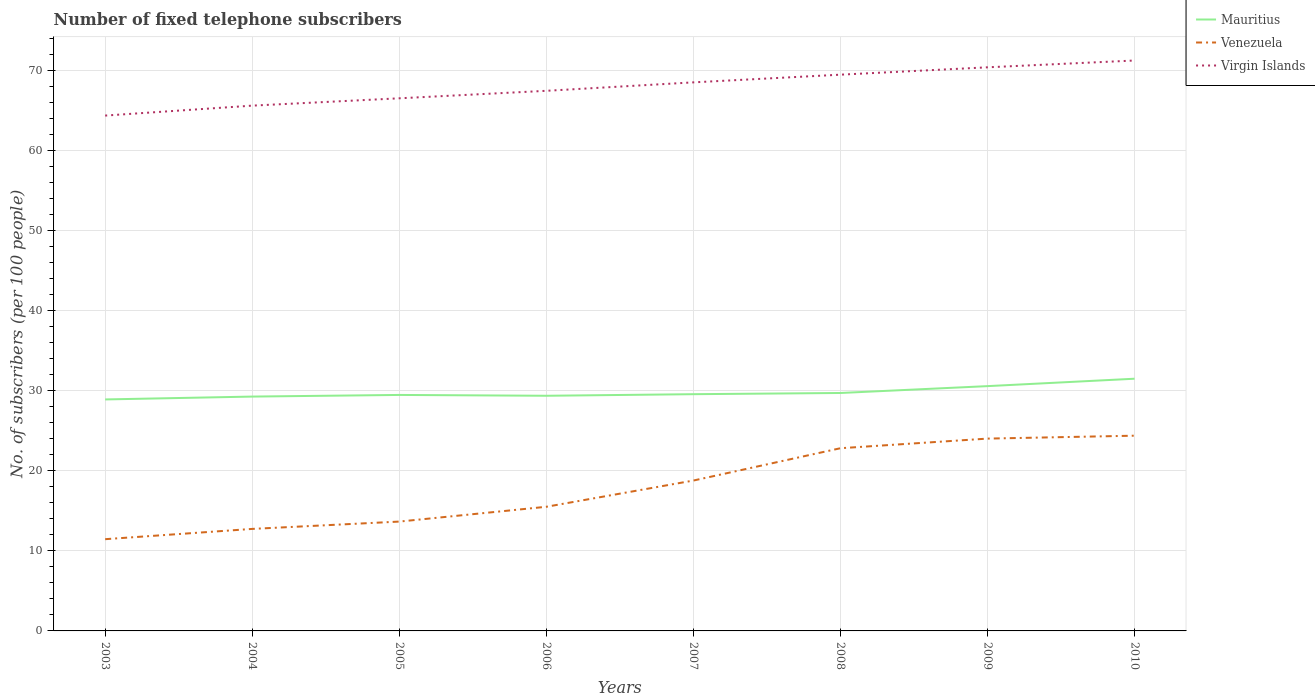Does the line corresponding to Venezuela intersect with the line corresponding to Mauritius?
Your answer should be very brief. No. Across all years, what is the maximum number of fixed telephone subscribers in Virgin Islands?
Offer a very short reply. 64.37. In which year was the number of fixed telephone subscribers in Venezuela maximum?
Your answer should be compact. 2003. What is the total number of fixed telephone subscribers in Venezuela in the graph?
Make the answer very short. -10.08. What is the difference between the highest and the second highest number of fixed telephone subscribers in Virgin Islands?
Give a very brief answer. 6.88. What is the difference between the highest and the lowest number of fixed telephone subscribers in Virgin Islands?
Make the answer very short. 4. What is the difference between two consecutive major ticks on the Y-axis?
Provide a short and direct response. 10. Are the values on the major ticks of Y-axis written in scientific E-notation?
Make the answer very short. No. Does the graph contain any zero values?
Provide a succinct answer. No. How many legend labels are there?
Your answer should be compact. 3. How are the legend labels stacked?
Give a very brief answer. Vertical. What is the title of the graph?
Offer a very short reply. Number of fixed telephone subscribers. Does "Papua New Guinea" appear as one of the legend labels in the graph?
Your response must be concise. No. What is the label or title of the Y-axis?
Provide a short and direct response. No. of subscribers (per 100 people). What is the No. of subscribers (per 100 people) in Mauritius in 2003?
Ensure brevity in your answer.  28.92. What is the No. of subscribers (per 100 people) in Venezuela in 2003?
Provide a succinct answer. 11.46. What is the No. of subscribers (per 100 people) of Virgin Islands in 2003?
Give a very brief answer. 64.37. What is the No. of subscribers (per 100 people) in Mauritius in 2004?
Ensure brevity in your answer.  29.27. What is the No. of subscribers (per 100 people) of Venezuela in 2004?
Your response must be concise. 12.74. What is the No. of subscribers (per 100 people) of Virgin Islands in 2004?
Make the answer very short. 65.62. What is the No. of subscribers (per 100 people) in Mauritius in 2005?
Offer a very short reply. 29.48. What is the No. of subscribers (per 100 people) of Venezuela in 2005?
Ensure brevity in your answer.  13.66. What is the No. of subscribers (per 100 people) of Virgin Islands in 2005?
Offer a terse response. 66.53. What is the No. of subscribers (per 100 people) in Mauritius in 2006?
Provide a short and direct response. 29.37. What is the No. of subscribers (per 100 people) in Venezuela in 2006?
Make the answer very short. 15.51. What is the No. of subscribers (per 100 people) in Virgin Islands in 2006?
Offer a terse response. 67.47. What is the No. of subscribers (per 100 people) in Mauritius in 2007?
Offer a very short reply. 29.57. What is the No. of subscribers (per 100 people) in Venezuela in 2007?
Your answer should be compact. 18.78. What is the No. of subscribers (per 100 people) of Virgin Islands in 2007?
Your answer should be compact. 68.52. What is the No. of subscribers (per 100 people) of Mauritius in 2008?
Make the answer very short. 29.72. What is the No. of subscribers (per 100 people) of Venezuela in 2008?
Provide a succinct answer. 22.82. What is the No. of subscribers (per 100 people) in Virgin Islands in 2008?
Give a very brief answer. 69.48. What is the No. of subscribers (per 100 people) of Mauritius in 2009?
Offer a very short reply. 30.58. What is the No. of subscribers (per 100 people) in Venezuela in 2009?
Your response must be concise. 24.02. What is the No. of subscribers (per 100 people) of Virgin Islands in 2009?
Your response must be concise. 70.4. What is the No. of subscribers (per 100 people) in Mauritius in 2010?
Provide a short and direct response. 31.5. What is the No. of subscribers (per 100 people) in Venezuela in 2010?
Keep it short and to the point. 24.39. What is the No. of subscribers (per 100 people) of Virgin Islands in 2010?
Make the answer very short. 71.25. Across all years, what is the maximum No. of subscribers (per 100 people) in Mauritius?
Ensure brevity in your answer.  31.5. Across all years, what is the maximum No. of subscribers (per 100 people) of Venezuela?
Make the answer very short. 24.39. Across all years, what is the maximum No. of subscribers (per 100 people) of Virgin Islands?
Your answer should be very brief. 71.25. Across all years, what is the minimum No. of subscribers (per 100 people) in Mauritius?
Provide a short and direct response. 28.92. Across all years, what is the minimum No. of subscribers (per 100 people) of Venezuela?
Keep it short and to the point. 11.46. Across all years, what is the minimum No. of subscribers (per 100 people) in Virgin Islands?
Your answer should be very brief. 64.37. What is the total No. of subscribers (per 100 people) in Mauritius in the graph?
Keep it short and to the point. 238.42. What is the total No. of subscribers (per 100 people) in Venezuela in the graph?
Make the answer very short. 143.39. What is the total No. of subscribers (per 100 people) in Virgin Islands in the graph?
Give a very brief answer. 543.65. What is the difference between the No. of subscribers (per 100 people) in Mauritius in 2003 and that in 2004?
Provide a succinct answer. -0.36. What is the difference between the No. of subscribers (per 100 people) of Venezuela in 2003 and that in 2004?
Keep it short and to the point. -1.28. What is the difference between the No. of subscribers (per 100 people) in Virgin Islands in 2003 and that in 2004?
Your response must be concise. -1.24. What is the difference between the No. of subscribers (per 100 people) of Mauritius in 2003 and that in 2005?
Offer a very short reply. -0.56. What is the difference between the No. of subscribers (per 100 people) in Venezuela in 2003 and that in 2005?
Provide a succinct answer. -2.2. What is the difference between the No. of subscribers (per 100 people) of Virgin Islands in 2003 and that in 2005?
Your answer should be compact. -2.16. What is the difference between the No. of subscribers (per 100 people) of Mauritius in 2003 and that in 2006?
Your answer should be compact. -0.46. What is the difference between the No. of subscribers (per 100 people) of Venezuela in 2003 and that in 2006?
Keep it short and to the point. -4.05. What is the difference between the No. of subscribers (per 100 people) in Virgin Islands in 2003 and that in 2006?
Your response must be concise. -3.09. What is the difference between the No. of subscribers (per 100 people) of Mauritius in 2003 and that in 2007?
Ensure brevity in your answer.  -0.65. What is the difference between the No. of subscribers (per 100 people) in Venezuela in 2003 and that in 2007?
Keep it short and to the point. -7.33. What is the difference between the No. of subscribers (per 100 people) in Virgin Islands in 2003 and that in 2007?
Ensure brevity in your answer.  -4.15. What is the difference between the No. of subscribers (per 100 people) in Mauritius in 2003 and that in 2008?
Give a very brief answer. -0.81. What is the difference between the No. of subscribers (per 100 people) of Venezuela in 2003 and that in 2008?
Make the answer very short. -11.36. What is the difference between the No. of subscribers (per 100 people) of Virgin Islands in 2003 and that in 2008?
Make the answer very short. -5.11. What is the difference between the No. of subscribers (per 100 people) of Mauritius in 2003 and that in 2009?
Offer a very short reply. -1.66. What is the difference between the No. of subscribers (per 100 people) in Venezuela in 2003 and that in 2009?
Offer a terse response. -12.56. What is the difference between the No. of subscribers (per 100 people) of Virgin Islands in 2003 and that in 2009?
Offer a terse response. -6.03. What is the difference between the No. of subscribers (per 100 people) of Mauritius in 2003 and that in 2010?
Offer a terse response. -2.59. What is the difference between the No. of subscribers (per 100 people) in Venezuela in 2003 and that in 2010?
Offer a very short reply. -12.93. What is the difference between the No. of subscribers (per 100 people) in Virgin Islands in 2003 and that in 2010?
Your answer should be compact. -6.88. What is the difference between the No. of subscribers (per 100 people) of Mauritius in 2004 and that in 2005?
Provide a succinct answer. -0.2. What is the difference between the No. of subscribers (per 100 people) of Venezuela in 2004 and that in 2005?
Give a very brief answer. -0.92. What is the difference between the No. of subscribers (per 100 people) in Virgin Islands in 2004 and that in 2005?
Ensure brevity in your answer.  -0.92. What is the difference between the No. of subscribers (per 100 people) of Mauritius in 2004 and that in 2006?
Provide a succinct answer. -0.1. What is the difference between the No. of subscribers (per 100 people) in Venezuela in 2004 and that in 2006?
Ensure brevity in your answer.  -2.77. What is the difference between the No. of subscribers (per 100 people) of Virgin Islands in 2004 and that in 2006?
Offer a very short reply. -1.85. What is the difference between the No. of subscribers (per 100 people) of Mauritius in 2004 and that in 2007?
Your answer should be very brief. -0.3. What is the difference between the No. of subscribers (per 100 people) of Venezuela in 2004 and that in 2007?
Offer a terse response. -6.04. What is the difference between the No. of subscribers (per 100 people) of Virgin Islands in 2004 and that in 2007?
Provide a succinct answer. -2.91. What is the difference between the No. of subscribers (per 100 people) in Mauritius in 2004 and that in 2008?
Your response must be concise. -0.45. What is the difference between the No. of subscribers (per 100 people) of Venezuela in 2004 and that in 2008?
Make the answer very short. -10.08. What is the difference between the No. of subscribers (per 100 people) in Virgin Islands in 2004 and that in 2008?
Give a very brief answer. -3.87. What is the difference between the No. of subscribers (per 100 people) of Mauritius in 2004 and that in 2009?
Give a very brief answer. -1.31. What is the difference between the No. of subscribers (per 100 people) in Venezuela in 2004 and that in 2009?
Provide a short and direct response. -11.28. What is the difference between the No. of subscribers (per 100 people) of Virgin Islands in 2004 and that in 2009?
Keep it short and to the point. -4.79. What is the difference between the No. of subscribers (per 100 people) of Mauritius in 2004 and that in 2010?
Offer a very short reply. -2.23. What is the difference between the No. of subscribers (per 100 people) of Venezuela in 2004 and that in 2010?
Offer a very short reply. -11.64. What is the difference between the No. of subscribers (per 100 people) of Virgin Islands in 2004 and that in 2010?
Your answer should be very brief. -5.64. What is the difference between the No. of subscribers (per 100 people) in Mauritius in 2005 and that in 2006?
Give a very brief answer. 0.1. What is the difference between the No. of subscribers (per 100 people) of Venezuela in 2005 and that in 2006?
Provide a succinct answer. -1.85. What is the difference between the No. of subscribers (per 100 people) in Virgin Islands in 2005 and that in 2006?
Offer a terse response. -0.94. What is the difference between the No. of subscribers (per 100 people) of Mauritius in 2005 and that in 2007?
Your answer should be compact. -0.09. What is the difference between the No. of subscribers (per 100 people) in Venezuela in 2005 and that in 2007?
Provide a succinct answer. -5.13. What is the difference between the No. of subscribers (per 100 people) in Virgin Islands in 2005 and that in 2007?
Your answer should be very brief. -1.99. What is the difference between the No. of subscribers (per 100 people) in Mauritius in 2005 and that in 2008?
Offer a very short reply. -0.24. What is the difference between the No. of subscribers (per 100 people) in Venezuela in 2005 and that in 2008?
Provide a short and direct response. -9.16. What is the difference between the No. of subscribers (per 100 people) of Virgin Islands in 2005 and that in 2008?
Your answer should be very brief. -2.95. What is the difference between the No. of subscribers (per 100 people) in Mauritius in 2005 and that in 2009?
Offer a very short reply. -1.1. What is the difference between the No. of subscribers (per 100 people) in Venezuela in 2005 and that in 2009?
Your response must be concise. -10.36. What is the difference between the No. of subscribers (per 100 people) in Virgin Islands in 2005 and that in 2009?
Your answer should be very brief. -3.87. What is the difference between the No. of subscribers (per 100 people) of Mauritius in 2005 and that in 2010?
Offer a terse response. -2.03. What is the difference between the No. of subscribers (per 100 people) of Venezuela in 2005 and that in 2010?
Offer a very short reply. -10.73. What is the difference between the No. of subscribers (per 100 people) in Virgin Islands in 2005 and that in 2010?
Make the answer very short. -4.72. What is the difference between the No. of subscribers (per 100 people) in Mauritius in 2006 and that in 2007?
Give a very brief answer. -0.2. What is the difference between the No. of subscribers (per 100 people) in Venezuela in 2006 and that in 2007?
Offer a very short reply. -3.28. What is the difference between the No. of subscribers (per 100 people) in Virgin Islands in 2006 and that in 2007?
Give a very brief answer. -1.06. What is the difference between the No. of subscribers (per 100 people) of Mauritius in 2006 and that in 2008?
Give a very brief answer. -0.35. What is the difference between the No. of subscribers (per 100 people) of Venezuela in 2006 and that in 2008?
Give a very brief answer. -7.31. What is the difference between the No. of subscribers (per 100 people) of Virgin Islands in 2006 and that in 2008?
Offer a terse response. -2.02. What is the difference between the No. of subscribers (per 100 people) of Mauritius in 2006 and that in 2009?
Offer a very short reply. -1.21. What is the difference between the No. of subscribers (per 100 people) in Venezuela in 2006 and that in 2009?
Offer a terse response. -8.52. What is the difference between the No. of subscribers (per 100 people) of Virgin Islands in 2006 and that in 2009?
Make the answer very short. -2.93. What is the difference between the No. of subscribers (per 100 people) in Mauritius in 2006 and that in 2010?
Ensure brevity in your answer.  -2.13. What is the difference between the No. of subscribers (per 100 people) in Venezuela in 2006 and that in 2010?
Your answer should be very brief. -8.88. What is the difference between the No. of subscribers (per 100 people) in Virgin Islands in 2006 and that in 2010?
Ensure brevity in your answer.  -3.78. What is the difference between the No. of subscribers (per 100 people) in Mauritius in 2007 and that in 2008?
Offer a very short reply. -0.15. What is the difference between the No. of subscribers (per 100 people) in Venezuela in 2007 and that in 2008?
Your answer should be compact. -4.04. What is the difference between the No. of subscribers (per 100 people) in Virgin Islands in 2007 and that in 2008?
Provide a short and direct response. -0.96. What is the difference between the No. of subscribers (per 100 people) of Mauritius in 2007 and that in 2009?
Your answer should be very brief. -1.01. What is the difference between the No. of subscribers (per 100 people) in Venezuela in 2007 and that in 2009?
Provide a succinct answer. -5.24. What is the difference between the No. of subscribers (per 100 people) in Virgin Islands in 2007 and that in 2009?
Offer a terse response. -1.88. What is the difference between the No. of subscribers (per 100 people) of Mauritius in 2007 and that in 2010?
Make the answer very short. -1.93. What is the difference between the No. of subscribers (per 100 people) in Venezuela in 2007 and that in 2010?
Your answer should be very brief. -5.6. What is the difference between the No. of subscribers (per 100 people) in Virgin Islands in 2007 and that in 2010?
Keep it short and to the point. -2.73. What is the difference between the No. of subscribers (per 100 people) in Mauritius in 2008 and that in 2009?
Offer a very short reply. -0.86. What is the difference between the No. of subscribers (per 100 people) of Venezuela in 2008 and that in 2009?
Provide a short and direct response. -1.2. What is the difference between the No. of subscribers (per 100 people) in Virgin Islands in 2008 and that in 2009?
Your response must be concise. -0.92. What is the difference between the No. of subscribers (per 100 people) of Mauritius in 2008 and that in 2010?
Provide a short and direct response. -1.78. What is the difference between the No. of subscribers (per 100 people) in Venezuela in 2008 and that in 2010?
Your response must be concise. -1.56. What is the difference between the No. of subscribers (per 100 people) of Virgin Islands in 2008 and that in 2010?
Provide a short and direct response. -1.77. What is the difference between the No. of subscribers (per 100 people) in Mauritius in 2009 and that in 2010?
Keep it short and to the point. -0.92. What is the difference between the No. of subscribers (per 100 people) in Venezuela in 2009 and that in 2010?
Your response must be concise. -0.36. What is the difference between the No. of subscribers (per 100 people) of Virgin Islands in 2009 and that in 2010?
Offer a terse response. -0.85. What is the difference between the No. of subscribers (per 100 people) in Mauritius in 2003 and the No. of subscribers (per 100 people) in Venezuela in 2004?
Ensure brevity in your answer.  16.17. What is the difference between the No. of subscribers (per 100 people) of Mauritius in 2003 and the No. of subscribers (per 100 people) of Virgin Islands in 2004?
Your answer should be compact. -36.7. What is the difference between the No. of subscribers (per 100 people) of Venezuela in 2003 and the No. of subscribers (per 100 people) of Virgin Islands in 2004?
Provide a short and direct response. -54.16. What is the difference between the No. of subscribers (per 100 people) in Mauritius in 2003 and the No. of subscribers (per 100 people) in Venezuela in 2005?
Provide a succinct answer. 15.26. What is the difference between the No. of subscribers (per 100 people) in Mauritius in 2003 and the No. of subscribers (per 100 people) in Virgin Islands in 2005?
Ensure brevity in your answer.  -37.62. What is the difference between the No. of subscribers (per 100 people) of Venezuela in 2003 and the No. of subscribers (per 100 people) of Virgin Islands in 2005?
Offer a very short reply. -55.07. What is the difference between the No. of subscribers (per 100 people) in Mauritius in 2003 and the No. of subscribers (per 100 people) in Venezuela in 2006?
Offer a very short reply. 13.41. What is the difference between the No. of subscribers (per 100 people) of Mauritius in 2003 and the No. of subscribers (per 100 people) of Virgin Islands in 2006?
Your answer should be very brief. -38.55. What is the difference between the No. of subscribers (per 100 people) in Venezuela in 2003 and the No. of subscribers (per 100 people) in Virgin Islands in 2006?
Your answer should be compact. -56.01. What is the difference between the No. of subscribers (per 100 people) of Mauritius in 2003 and the No. of subscribers (per 100 people) of Venezuela in 2007?
Provide a short and direct response. 10.13. What is the difference between the No. of subscribers (per 100 people) of Mauritius in 2003 and the No. of subscribers (per 100 people) of Virgin Islands in 2007?
Give a very brief answer. -39.61. What is the difference between the No. of subscribers (per 100 people) in Venezuela in 2003 and the No. of subscribers (per 100 people) in Virgin Islands in 2007?
Ensure brevity in your answer.  -57.06. What is the difference between the No. of subscribers (per 100 people) in Mauritius in 2003 and the No. of subscribers (per 100 people) in Venezuela in 2008?
Provide a succinct answer. 6.09. What is the difference between the No. of subscribers (per 100 people) of Mauritius in 2003 and the No. of subscribers (per 100 people) of Virgin Islands in 2008?
Make the answer very short. -40.57. What is the difference between the No. of subscribers (per 100 people) of Venezuela in 2003 and the No. of subscribers (per 100 people) of Virgin Islands in 2008?
Provide a succinct answer. -58.02. What is the difference between the No. of subscribers (per 100 people) in Mauritius in 2003 and the No. of subscribers (per 100 people) in Venezuela in 2009?
Your response must be concise. 4.89. What is the difference between the No. of subscribers (per 100 people) in Mauritius in 2003 and the No. of subscribers (per 100 people) in Virgin Islands in 2009?
Offer a very short reply. -41.49. What is the difference between the No. of subscribers (per 100 people) of Venezuela in 2003 and the No. of subscribers (per 100 people) of Virgin Islands in 2009?
Make the answer very short. -58.94. What is the difference between the No. of subscribers (per 100 people) in Mauritius in 2003 and the No. of subscribers (per 100 people) in Venezuela in 2010?
Your response must be concise. 4.53. What is the difference between the No. of subscribers (per 100 people) of Mauritius in 2003 and the No. of subscribers (per 100 people) of Virgin Islands in 2010?
Keep it short and to the point. -42.34. What is the difference between the No. of subscribers (per 100 people) in Venezuela in 2003 and the No. of subscribers (per 100 people) in Virgin Islands in 2010?
Keep it short and to the point. -59.79. What is the difference between the No. of subscribers (per 100 people) of Mauritius in 2004 and the No. of subscribers (per 100 people) of Venezuela in 2005?
Give a very brief answer. 15.61. What is the difference between the No. of subscribers (per 100 people) of Mauritius in 2004 and the No. of subscribers (per 100 people) of Virgin Islands in 2005?
Provide a short and direct response. -37.26. What is the difference between the No. of subscribers (per 100 people) in Venezuela in 2004 and the No. of subscribers (per 100 people) in Virgin Islands in 2005?
Your response must be concise. -53.79. What is the difference between the No. of subscribers (per 100 people) of Mauritius in 2004 and the No. of subscribers (per 100 people) of Venezuela in 2006?
Offer a very short reply. 13.76. What is the difference between the No. of subscribers (per 100 people) of Mauritius in 2004 and the No. of subscribers (per 100 people) of Virgin Islands in 2006?
Provide a short and direct response. -38.2. What is the difference between the No. of subscribers (per 100 people) of Venezuela in 2004 and the No. of subscribers (per 100 people) of Virgin Islands in 2006?
Ensure brevity in your answer.  -54.73. What is the difference between the No. of subscribers (per 100 people) of Mauritius in 2004 and the No. of subscribers (per 100 people) of Venezuela in 2007?
Your answer should be very brief. 10.49. What is the difference between the No. of subscribers (per 100 people) of Mauritius in 2004 and the No. of subscribers (per 100 people) of Virgin Islands in 2007?
Provide a succinct answer. -39.25. What is the difference between the No. of subscribers (per 100 people) in Venezuela in 2004 and the No. of subscribers (per 100 people) in Virgin Islands in 2007?
Ensure brevity in your answer.  -55.78. What is the difference between the No. of subscribers (per 100 people) in Mauritius in 2004 and the No. of subscribers (per 100 people) in Venezuela in 2008?
Your response must be concise. 6.45. What is the difference between the No. of subscribers (per 100 people) in Mauritius in 2004 and the No. of subscribers (per 100 people) in Virgin Islands in 2008?
Offer a terse response. -40.21. What is the difference between the No. of subscribers (per 100 people) of Venezuela in 2004 and the No. of subscribers (per 100 people) of Virgin Islands in 2008?
Offer a terse response. -56.74. What is the difference between the No. of subscribers (per 100 people) of Mauritius in 2004 and the No. of subscribers (per 100 people) of Venezuela in 2009?
Provide a short and direct response. 5.25. What is the difference between the No. of subscribers (per 100 people) of Mauritius in 2004 and the No. of subscribers (per 100 people) of Virgin Islands in 2009?
Keep it short and to the point. -41.13. What is the difference between the No. of subscribers (per 100 people) in Venezuela in 2004 and the No. of subscribers (per 100 people) in Virgin Islands in 2009?
Keep it short and to the point. -57.66. What is the difference between the No. of subscribers (per 100 people) in Mauritius in 2004 and the No. of subscribers (per 100 people) in Venezuela in 2010?
Keep it short and to the point. 4.89. What is the difference between the No. of subscribers (per 100 people) in Mauritius in 2004 and the No. of subscribers (per 100 people) in Virgin Islands in 2010?
Keep it short and to the point. -41.98. What is the difference between the No. of subscribers (per 100 people) of Venezuela in 2004 and the No. of subscribers (per 100 people) of Virgin Islands in 2010?
Keep it short and to the point. -58.51. What is the difference between the No. of subscribers (per 100 people) of Mauritius in 2005 and the No. of subscribers (per 100 people) of Venezuela in 2006?
Give a very brief answer. 13.97. What is the difference between the No. of subscribers (per 100 people) of Mauritius in 2005 and the No. of subscribers (per 100 people) of Virgin Islands in 2006?
Provide a short and direct response. -37.99. What is the difference between the No. of subscribers (per 100 people) in Venezuela in 2005 and the No. of subscribers (per 100 people) in Virgin Islands in 2006?
Provide a short and direct response. -53.81. What is the difference between the No. of subscribers (per 100 people) of Mauritius in 2005 and the No. of subscribers (per 100 people) of Venezuela in 2007?
Give a very brief answer. 10.69. What is the difference between the No. of subscribers (per 100 people) of Mauritius in 2005 and the No. of subscribers (per 100 people) of Virgin Islands in 2007?
Provide a short and direct response. -39.05. What is the difference between the No. of subscribers (per 100 people) of Venezuela in 2005 and the No. of subscribers (per 100 people) of Virgin Islands in 2007?
Offer a very short reply. -54.86. What is the difference between the No. of subscribers (per 100 people) of Mauritius in 2005 and the No. of subscribers (per 100 people) of Venezuela in 2008?
Make the answer very short. 6.66. What is the difference between the No. of subscribers (per 100 people) of Mauritius in 2005 and the No. of subscribers (per 100 people) of Virgin Islands in 2008?
Offer a very short reply. -40.01. What is the difference between the No. of subscribers (per 100 people) of Venezuela in 2005 and the No. of subscribers (per 100 people) of Virgin Islands in 2008?
Provide a short and direct response. -55.82. What is the difference between the No. of subscribers (per 100 people) in Mauritius in 2005 and the No. of subscribers (per 100 people) in Venezuela in 2009?
Your answer should be compact. 5.45. What is the difference between the No. of subscribers (per 100 people) of Mauritius in 2005 and the No. of subscribers (per 100 people) of Virgin Islands in 2009?
Offer a terse response. -40.93. What is the difference between the No. of subscribers (per 100 people) in Venezuela in 2005 and the No. of subscribers (per 100 people) in Virgin Islands in 2009?
Keep it short and to the point. -56.74. What is the difference between the No. of subscribers (per 100 people) of Mauritius in 2005 and the No. of subscribers (per 100 people) of Venezuela in 2010?
Provide a succinct answer. 5.09. What is the difference between the No. of subscribers (per 100 people) of Mauritius in 2005 and the No. of subscribers (per 100 people) of Virgin Islands in 2010?
Your response must be concise. -41.78. What is the difference between the No. of subscribers (per 100 people) of Venezuela in 2005 and the No. of subscribers (per 100 people) of Virgin Islands in 2010?
Keep it short and to the point. -57.59. What is the difference between the No. of subscribers (per 100 people) of Mauritius in 2006 and the No. of subscribers (per 100 people) of Venezuela in 2007?
Your answer should be very brief. 10.59. What is the difference between the No. of subscribers (per 100 people) of Mauritius in 2006 and the No. of subscribers (per 100 people) of Virgin Islands in 2007?
Offer a terse response. -39.15. What is the difference between the No. of subscribers (per 100 people) of Venezuela in 2006 and the No. of subscribers (per 100 people) of Virgin Islands in 2007?
Give a very brief answer. -53.02. What is the difference between the No. of subscribers (per 100 people) in Mauritius in 2006 and the No. of subscribers (per 100 people) in Venezuela in 2008?
Provide a short and direct response. 6.55. What is the difference between the No. of subscribers (per 100 people) in Mauritius in 2006 and the No. of subscribers (per 100 people) in Virgin Islands in 2008?
Make the answer very short. -40.11. What is the difference between the No. of subscribers (per 100 people) in Venezuela in 2006 and the No. of subscribers (per 100 people) in Virgin Islands in 2008?
Make the answer very short. -53.98. What is the difference between the No. of subscribers (per 100 people) of Mauritius in 2006 and the No. of subscribers (per 100 people) of Venezuela in 2009?
Offer a very short reply. 5.35. What is the difference between the No. of subscribers (per 100 people) in Mauritius in 2006 and the No. of subscribers (per 100 people) in Virgin Islands in 2009?
Your answer should be very brief. -41.03. What is the difference between the No. of subscribers (per 100 people) in Venezuela in 2006 and the No. of subscribers (per 100 people) in Virgin Islands in 2009?
Ensure brevity in your answer.  -54.89. What is the difference between the No. of subscribers (per 100 people) of Mauritius in 2006 and the No. of subscribers (per 100 people) of Venezuela in 2010?
Provide a succinct answer. 4.99. What is the difference between the No. of subscribers (per 100 people) of Mauritius in 2006 and the No. of subscribers (per 100 people) of Virgin Islands in 2010?
Make the answer very short. -41.88. What is the difference between the No. of subscribers (per 100 people) of Venezuela in 2006 and the No. of subscribers (per 100 people) of Virgin Islands in 2010?
Offer a terse response. -55.74. What is the difference between the No. of subscribers (per 100 people) in Mauritius in 2007 and the No. of subscribers (per 100 people) in Venezuela in 2008?
Offer a terse response. 6.75. What is the difference between the No. of subscribers (per 100 people) in Mauritius in 2007 and the No. of subscribers (per 100 people) in Virgin Islands in 2008?
Keep it short and to the point. -39.91. What is the difference between the No. of subscribers (per 100 people) in Venezuela in 2007 and the No. of subscribers (per 100 people) in Virgin Islands in 2008?
Make the answer very short. -50.7. What is the difference between the No. of subscribers (per 100 people) in Mauritius in 2007 and the No. of subscribers (per 100 people) in Venezuela in 2009?
Offer a terse response. 5.55. What is the difference between the No. of subscribers (per 100 people) in Mauritius in 2007 and the No. of subscribers (per 100 people) in Virgin Islands in 2009?
Offer a terse response. -40.83. What is the difference between the No. of subscribers (per 100 people) of Venezuela in 2007 and the No. of subscribers (per 100 people) of Virgin Islands in 2009?
Offer a terse response. -51.62. What is the difference between the No. of subscribers (per 100 people) in Mauritius in 2007 and the No. of subscribers (per 100 people) in Venezuela in 2010?
Offer a very short reply. 5.18. What is the difference between the No. of subscribers (per 100 people) in Mauritius in 2007 and the No. of subscribers (per 100 people) in Virgin Islands in 2010?
Your response must be concise. -41.68. What is the difference between the No. of subscribers (per 100 people) of Venezuela in 2007 and the No. of subscribers (per 100 people) of Virgin Islands in 2010?
Ensure brevity in your answer.  -52.47. What is the difference between the No. of subscribers (per 100 people) in Mauritius in 2008 and the No. of subscribers (per 100 people) in Venezuela in 2009?
Your answer should be compact. 5.7. What is the difference between the No. of subscribers (per 100 people) of Mauritius in 2008 and the No. of subscribers (per 100 people) of Virgin Islands in 2009?
Offer a very short reply. -40.68. What is the difference between the No. of subscribers (per 100 people) in Venezuela in 2008 and the No. of subscribers (per 100 people) in Virgin Islands in 2009?
Make the answer very short. -47.58. What is the difference between the No. of subscribers (per 100 people) in Mauritius in 2008 and the No. of subscribers (per 100 people) in Venezuela in 2010?
Ensure brevity in your answer.  5.33. What is the difference between the No. of subscribers (per 100 people) of Mauritius in 2008 and the No. of subscribers (per 100 people) of Virgin Islands in 2010?
Give a very brief answer. -41.53. What is the difference between the No. of subscribers (per 100 people) in Venezuela in 2008 and the No. of subscribers (per 100 people) in Virgin Islands in 2010?
Provide a short and direct response. -48.43. What is the difference between the No. of subscribers (per 100 people) of Mauritius in 2009 and the No. of subscribers (per 100 people) of Venezuela in 2010?
Give a very brief answer. 6.19. What is the difference between the No. of subscribers (per 100 people) of Mauritius in 2009 and the No. of subscribers (per 100 people) of Virgin Islands in 2010?
Your answer should be compact. -40.67. What is the difference between the No. of subscribers (per 100 people) in Venezuela in 2009 and the No. of subscribers (per 100 people) in Virgin Islands in 2010?
Make the answer very short. -47.23. What is the average No. of subscribers (per 100 people) of Mauritius per year?
Make the answer very short. 29.8. What is the average No. of subscribers (per 100 people) of Venezuela per year?
Your response must be concise. 17.92. What is the average No. of subscribers (per 100 people) of Virgin Islands per year?
Your answer should be compact. 67.96. In the year 2003, what is the difference between the No. of subscribers (per 100 people) in Mauritius and No. of subscribers (per 100 people) in Venezuela?
Provide a short and direct response. 17.46. In the year 2003, what is the difference between the No. of subscribers (per 100 people) in Mauritius and No. of subscribers (per 100 people) in Virgin Islands?
Your answer should be compact. -35.46. In the year 2003, what is the difference between the No. of subscribers (per 100 people) in Venezuela and No. of subscribers (per 100 people) in Virgin Islands?
Offer a very short reply. -52.91. In the year 2004, what is the difference between the No. of subscribers (per 100 people) of Mauritius and No. of subscribers (per 100 people) of Venezuela?
Provide a succinct answer. 16.53. In the year 2004, what is the difference between the No. of subscribers (per 100 people) of Mauritius and No. of subscribers (per 100 people) of Virgin Islands?
Your answer should be compact. -36.34. In the year 2004, what is the difference between the No. of subscribers (per 100 people) of Venezuela and No. of subscribers (per 100 people) of Virgin Islands?
Offer a terse response. -52.87. In the year 2005, what is the difference between the No. of subscribers (per 100 people) of Mauritius and No. of subscribers (per 100 people) of Venezuela?
Your response must be concise. 15.82. In the year 2005, what is the difference between the No. of subscribers (per 100 people) of Mauritius and No. of subscribers (per 100 people) of Virgin Islands?
Ensure brevity in your answer.  -37.05. In the year 2005, what is the difference between the No. of subscribers (per 100 people) in Venezuela and No. of subscribers (per 100 people) in Virgin Islands?
Your answer should be very brief. -52.87. In the year 2006, what is the difference between the No. of subscribers (per 100 people) of Mauritius and No. of subscribers (per 100 people) of Venezuela?
Offer a terse response. 13.87. In the year 2006, what is the difference between the No. of subscribers (per 100 people) in Mauritius and No. of subscribers (per 100 people) in Virgin Islands?
Your answer should be compact. -38.09. In the year 2006, what is the difference between the No. of subscribers (per 100 people) of Venezuela and No. of subscribers (per 100 people) of Virgin Islands?
Offer a terse response. -51.96. In the year 2007, what is the difference between the No. of subscribers (per 100 people) of Mauritius and No. of subscribers (per 100 people) of Venezuela?
Your answer should be compact. 10.79. In the year 2007, what is the difference between the No. of subscribers (per 100 people) in Mauritius and No. of subscribers (per 100 people) in Virgin Islands?
Provide a short and direct response. -38.95. In the year 2007, what is the difference between the No. of subscribers (per 100 people) in Venezuela and No. of subscribers (per 100 people) in Virgin Islands?
Give a very brief answer. -49.74. In the year 2008, what is the difference between the No. of subscribers (per 100 people) in Mauritius and No. of subscribers (per 100 people) in Venezuela?
Provide a succinct answer. 6.9. In the year 2008, what is the difference between the No. of subscribers (per 100 people) of Mauritius and No. of subscribers (per 100 people) of Virgin Islands?
Your response must be concise. -39.76. In the year 2008, what is the difference between the No. of subscribers (per 100 people) in Venezuela and No. of subscribers (per 100 people) in Virgin Islands?
Your response must be concise. -46.66. In the year 2009, what is the difference between the No. of subscribers (per 100 people) in Mauritius and No. of subscribers (per 100 people) in Venezuela?
Your answer should be compact. 6.56. In the year 2009, what is the difference between the No. of subscribers (per 100 people) in Mauritius and No. of subscribers (per 100 people) in Virgin Islands?
Offer a terse response. -39.82. In the year 2009, what is the difference between the No. of subscribers (per 100 people) in Venezuela and No. of subscribers (per 100 people) in Virgin Islands?
Provide a succinct answer. -46.38. In the year 2010, what is the difference between the No. of subscribers (per 100 people) of Mauritius and No. of subscribers (per 100 people) of Venezuela?
Provide a succinct answer. 7.12. In the year 2010, what is the difference between the No. of subscribers (per 100 people) of Mauritius and No. of subscribers (per 100 people) of Virgin Islands?
Offer a terse response. -39.75. In the year 2010, what is the difference between the No. of subscribers (per 100 people) of Venezuela and No. of subscribers (per 100 people) of Virgin Islands?
Give a very brief answer. -46.87. What is the ratio of the No. of subscribers (per 100 people) in Mauritius in 2003 to that in 2004?
Provide a succinct answer. 0.99. What is the ratio of the No. of subscribers (per 100 people) in Venezuela in 2003 to that in 2004?
Give a very brief answer. 0.9. What is the ratio of the No. of subscribers (per 100 people) of Virgin Islands in 2003 to that in 2004?
Your response must be concise. 0.98. What is the ratio of the No. of subscribers (per 100 people) in Venezuela in 2003 to that in 2005?
Offer a terse response. 0.84. What is the ratio of the No. of subscribers (per 100 people) in Virgin Islands in 2003 to that in 2005?
Ensure brevity in your answer.  0.97. What is the ratio of the No. of subscribers (per 100 people) of Mauritius in 2003 to that in 2006?
Your answer should be compact. 0.98. What is the ratio of the No. of subscribers (per 100 people) in Venezuela in 2003 to that in 2006?
Provide a succinct answer. 0.74. What is the ratio of the No. of subscribers (per 100 people) of Virgin Islands in 2003 to that in 2006?
Make the answer very short. 0.95. What is the ratio of the No. of subscribers (per 100 people) of Mauritius in 2003 to that in 2007?
Keep it short and to the point. 0.98. What is the ratio of the No. of subscribers (per 100 people) of Venezuela in 2003 to that in 2007?
Offer a very short reply. 0.61. What is the ratio of the No. of subscribers (per 100 people) of Virgin Islands in 2003 to that in 2007?
Offer a terse response. 0.94. What is the ratio of the No. of subscribers (per 100 people) in Mauritius in 2003 to that in 2008?
Provide a short and direct response. 0.97. What is the ratio of the No. of subscribers (per 100 people) in Venezuela in 2003 to that in 2008?
Give a very brief answer. 0.5. What is the ratio of the No. of subscribers (per 100 people) in Virgin Islands in 2003 to that in 2008?
Provide a succinct answer. 0.93. What is the ratio of the No. of subscribers (per 100 people) of Mauritius in 2003 to that in 2009?
Offer a terse response. 0.95. What is the ratio of the No. of subscribers (per 100 people) in Venezuela in 2003 to that in 2009?
Your response must be concise. 0.48. What is the ratio of the No. of subscribers (per 100 people) in Virgin Islands in 2003 to that in 2009?
Offer a terse response. 0.91. What is the ratio of the No. of subscribers (per 100 people) of Mauritius in 2003 to that in 2010?
Keep it short and to the point. 0.92. What is the ratio of the No. of subscribers (per 100 people) in Venezuela in 2003 to that in 2010?
Your response must be concise. 0.47. What is the ratio of the No. of subscribers (per 100 people) in Virgin Islands in 2003 to that in 2010?
Offer a very short reply. 0.9. What is the ratio of the No. of subscribers (per 100 people) of Mauritius in 2004 to that in 2005?
Give a very brief answer. 0.99. What is the ratio of the No. of subscribers (per 100 people) in Venezuela in 2004 to that in 2005?
Provide a short and direct response. 0.93. What is the ratio of the No. of subscribers (per 100 people) in Virgin Islands in 2004 to that in 2005?
Ensure brevity in your answer.  0.99. What is the ratio of the No. of subscribers (per 100 people) in Venezuela in 2004 to that in 2006?
Keep it short and to the point. 0.82. What is the ratio of the No. of subscribers (per 100 people) of Virgin Islands in 2004 to that in 2006?
Provide a short and direct response. 0.97. What is the ratio of the No. of subscribers (per 100 people) of Venezuela in 2004 to that in 2007?
Keep it short and to the point. 0.68. What is the ratio of the No. of subscribers (per 100 people) in Virgin Islands in 2004 to that in 2007?
Ensure brevity in your answer.  0.96. What is the ratio of the No. of subscribers (per 100 people) of Mauritius in 2004 to that in 2008?
Offer a very short reply. 0.98. What is the ratio of the No. of subscribers (per 100 people) of Venezuela in 2004 to that in 2008?
Your answer should be compact. 0.56. What is the ratio of the No. of subscribers (per 100 people) in Virgin Islands in 2004 to that in 2008?
Ensure brevity in your answer.  0.94. What is the ratio of the No. of subscribers (per 100 people) of Mauritius in 2004 to that in 2009?
Offer a terse response. 0.96. What is the ratio of the No. of subscribers (per 100 people) in Venezuela in 2004 to that in 2009?
Offer a very short reply. 0.53. What is the ratio of the No. of subscribers (per 100 people) in Virgin Islands in 2004 to that in 2009?
Offer a very short reply. 0.93. What is the ratio of the No. of subscribers (per 100 people) of Mauritius in 2004 to that in 2010?
Offer a terse response. 0.93. What is the ratio of the No. of subscribers (per 100 people) of Venezuela in 2004 to that in 2010?
Provide a short and direct response. 0.52. What is the ratio of the No. of subscribers (per 100 people) of Virgin Islands in 2004 to that in 2010?
Offer a very short reply. 0.92. What is the ratio of the No. of subscribers (per 100 people) in Venezuela in 2005 to that in 2006?
Keep it short and to the point. 0.88. What is the ratio of the No. of subscribers (per 100 people) of Virgin Islands in 2005 to that in 2006?
Provide a short and direct response. 0.99. What is the ratio of the No. of subscribers (per 100 people) in Mauritius in 2005 to that in 2007?
Ensure brevity in your answer.  1. What is the ratio of the No. of subscribers (per 100 people) in Venezuela in 2005 to that in 2007?
Your answer should be compact. 0.73. What is the ratio of the No. of subscribers (per 100 people) of Virgin Islands in 2005 to that in 2007?
Your answer should be compact. 0.97. What is the ratio of the No. of subscribers (per 100 people) of Mauritius in 2005 to that in 2008?
Give a very brief answer. 0.99. What is the ratio of the No. of subscribers (per 100 people) of Venezuela in 2005 to that in 2008?
Your response must be concise. 0.6. What is the ratio of the No. of subscribers (per 100 people) of Virgin Islands in 2005 to that in 2008?
Provide a succinct answer. 0.96. What is the ratio of the No. of subscribers (per 100 people) of Mauritius in 2005 to that in 2009?
Offer a terse response. 0.96. What is the ratio of the No. of subscribers (per 100 people) in Venezuela in 2005 to that in 2009?
Offer a terse response. 0.57. What is the ratio of the No. of subscribers (per 100 people) in Virgin Islands in 2005 to that in 2009?
Provide a succinct answer. 0.94. What is the ratio of the No. of subscribers (per 100 people) of Mauritius in 2005 to that in 2010?
Provide a succinct answer. 0.94. What is the ratio of the No. of subscribers (per 100 people) in Venezuela in 2005 to that in 2010?
Make the answer very short. 0.56. What is the ratio of the No. of subscribers (per 100 people) of Virgin Islands in 2005 to that in 2010?
Your answer should be very brief. 0.93. What is the ratio of the No. of subscribers (per 100 people) of Venezuela in 2006 to that in 2007?
Provide a succinct answer. 0.83. What is the ratio of the No. of subscribers (per 100 people) of Virgin Islands in 2006 to that in 2007?
Provide a short and direct response. 0.98. What is the ratio of the No. of subscribers (per 100 people) of Mauritius in 2006 to that in 2008?
Make the answer very short. 0.99. What is the ratio of the No. of subscribers (per 100 people) of Venezuela in 2006 to that in 2008?
Give a very brief answer. 0.68. What is the ratio of the No. of subscribers (per 100 people) in Mauritius in 2006 to that in 2009?
Your answer should be very brief. 0.96. What is the ratio of the No. of subscribers (per 100 people) in Venezuela in 2006 to that in 2009?
Make the answer very short. 0.65. What is the ratio of the No. of subscribers (per 100 people) in Virgin Islands in 2006 to that in 2009?
Ensure brevity in your answer.  0.96. What is the ratio of the No. of subscribers (per 100 people) in Mauritius in 2006 to that in 2010?
Your answer should be compact. 0.93. What is the ratio of the No. of subscribers (per 100 people) of Venezuela in 2006 to that in 2010?
Keep it short and to the point. 0.64. What is the ratio of the No. of subscribers (per 100 people) in Virgin Islands in 2006 to that in 2010?
Your answer should be compact. 0.95. What is the ratio of the No. of subscribers (per 100 people) in Venezuela in 2007 to that in 2008?
Your response must be concise. 0.82. What is the ratio of the No. of subscribers (per 100 people) of Virgin Islands in 2007 to that in 2008?
Provide a succinct answer. 0.99. What is the ratio of the No. of subscribers (per 100 people) in Venezuela in 2007 to that in 2009?
Your response must be concise. 0.78. What is the ratio of the No. of subscribers (per 100 people) in Virgin Islands in 2007 to that in 2009?
Your response must be concise. 0.97. What is the ratio of the No. of subscribers (per 100 people) of Mauritius in 2007 to that in 2010?
Your answer should be compact. 0.94. What is the ratio of the No. of subscribers (per 100 people) in Venezuela in 2007 to that in 2010?
Your response must be concise. 0.77. What is the ratio of the No. of subscribers (per 100 people) of Virgin Islands in 2007 to that in 2010?
Your answer should be compact. 0.96. What is the ratio of the No. of subscribers (per 100 people) in Mauritius in 2008 to that in 2009?
Make the answer very short. 0.97. What is the ratio of the No. of subscribers (per 100 people) in Virgin Islands in 2008 to that in 2009?
Offer a terse response. 0.99. What is the ratio of the No. of subscribers (per 100 people) in Mauritius in 2008 to that in 2010?
Your response must be concise. 0.94. What is the ratio of the No. of subscribers (per 100 people) of Venezuela in 2008 to that in 2010?
Offer a very short reply. 0.94. What is the ratio of the No. of subscribers (per 100 people) in Virgin Islands in 2008 to that in 2010?
Give a very brief answer. 0.98. What is the ratio of the No. of subscribers (per 100 people) of Mauritius in 2009 to that in 2010?
Make the answer very short. 0.97. What is the ratio of the No. of subscribers (per 100 people) of Venezuela in 2009 to that in 2010?
Give a very brief answer. 0.99. What is the difference between the highest and the second highest No. of subscribers (per 100 people) in Mauritius?
Keep it short and to the point. 0.92. What is the difference between the highest and the second highest No. of subscribers (per 100 people) in Venezuela?
Give a very brief answer. 0.36. What is the difference between the highest and the second highest No. of subscribers (per 100 people) of Virgin Islands?
Ensure brevity in your answer.  0.85. What is the difference between the highest and the lowest No. of subscribers (per 100 people) of Mauritius?
Your response must be concise. 2.59. What is the difference between the highest and the lowest No. of subscribers (per 100 people) in Venezuela?
Provide a succinct answer. 12.93. What is the difference between the highest and the lowest No. of subscribers (per 100 people) of Virgin Islands?
Keep it short and to the point. 6.88. 